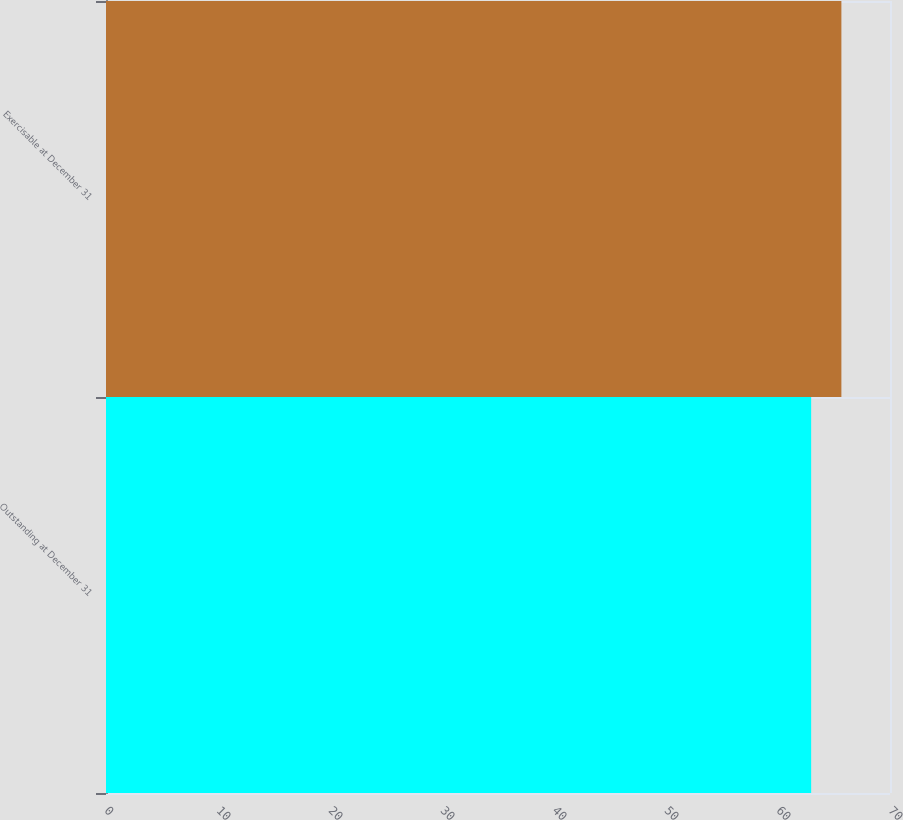<chart> <loc_0><loc_0><loc_500><loc_500><bar_chart><fcel>Outstanding at December 31<fcel>Exercisable at December 31<nl><fcel>62.96<fcel>65.66<nl></chart> 